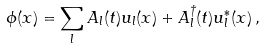<formula> <loc_0><loc_0><loc_500><loc_500>\phi ( x ) = \sum _ { l } A _ { l } ( t ) u _ { l } ( x ) + A ^ { \dagger } _ { l } ( t ) u ^ { * } _ { l } ( x ) \, ,</formula> 